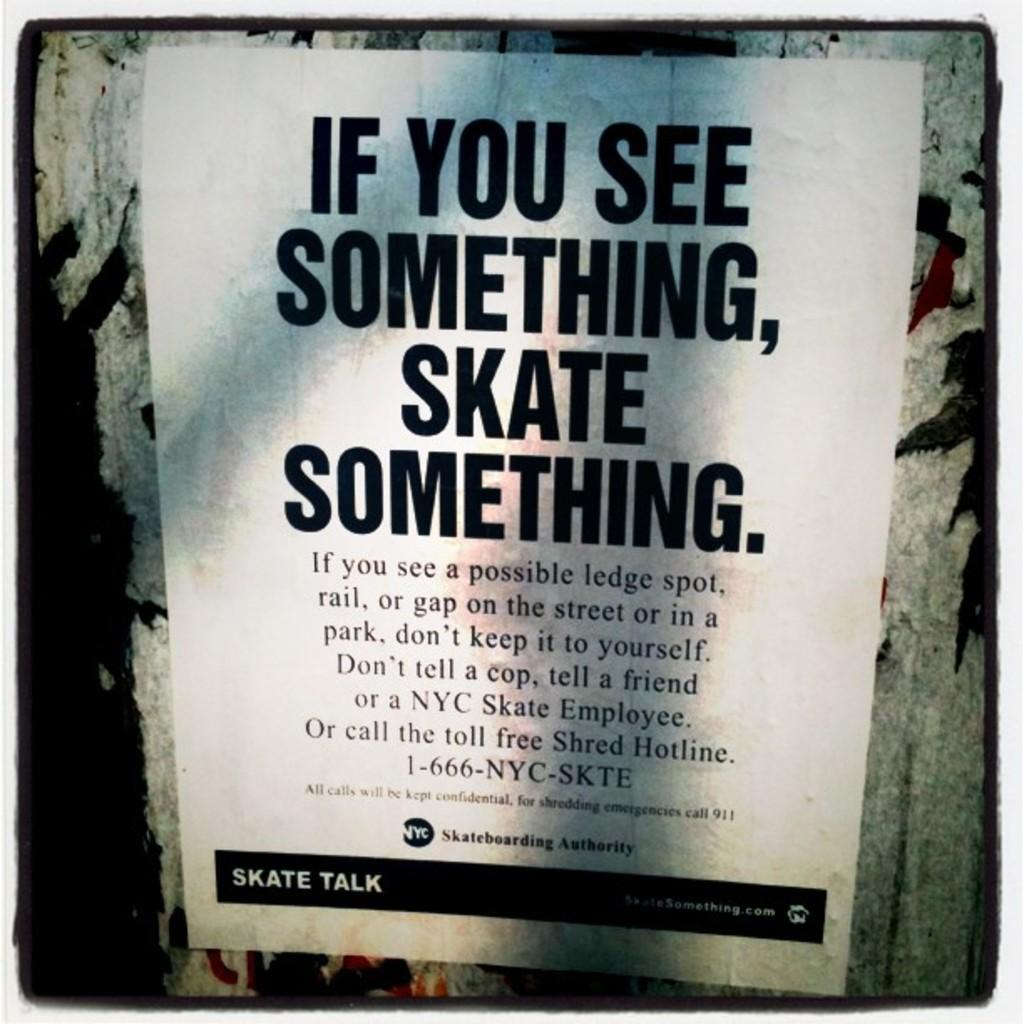Provide a one-sentence caption for the provided image. A black and white poster supporting Skating, and sharing of rails, and ledge spots seen. 